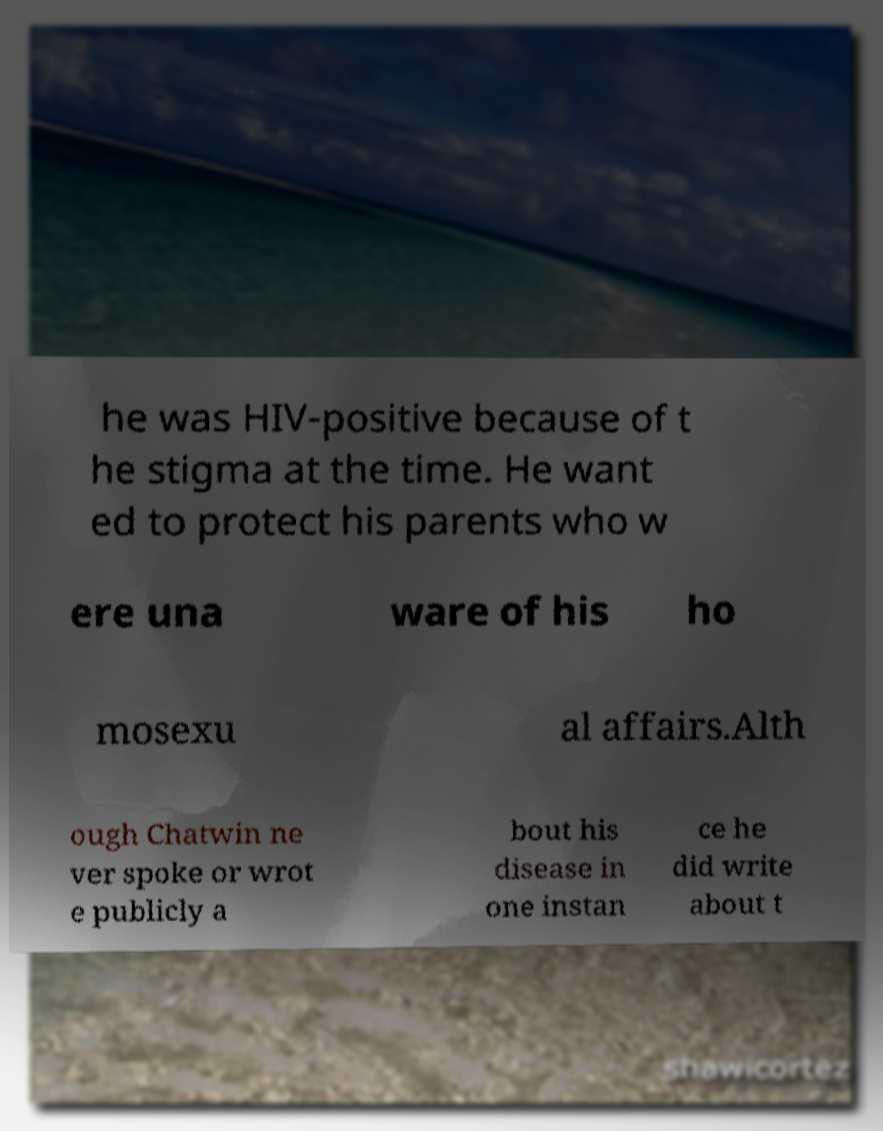Could you extract and type out the text from this image? he was HIV-positive because of t he stigma at the time. He want ed to protect his parents who w ere una ware of his ho mosexu al affairs.Alth ough Chatwin ne ver spoke or wrot e publicly a bout his disease in one instan ce he did write about t 